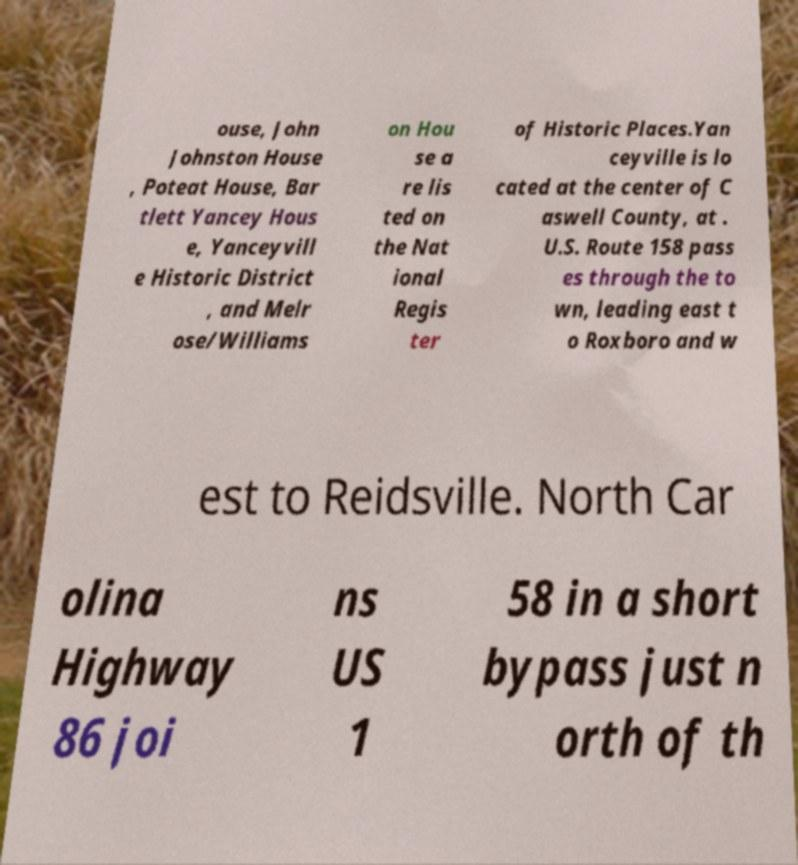Can you read and provide the text displayed in the image?This photo seems to have some interesting text. Can you extract and type it out for me? ouse, John Johnston House , Poteat House, Bar tlett Yancey Hous e, Yanceyvill e Historic District , and Melr ose/Williams on Hou se a re lis ted on the Nat ional Regis ter of Historic Places.Yan ceyville is lo cated at the center of C aswell County, at . U.S. Route 158 pass es through the to wn, leading east t o Roxboro and w est to Reidsville. North Car olina Highway 86 joi ns US 1 58 in a short bypass just n orth of th 